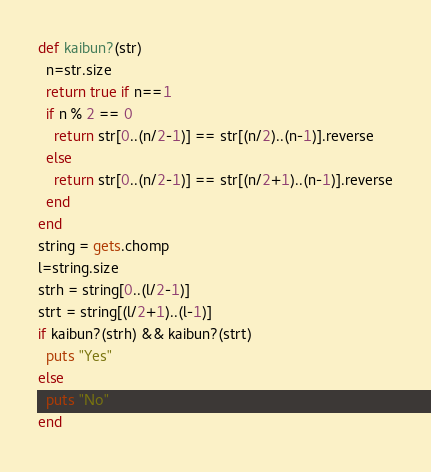Convert code to text. <code><loc_0><loc_0><loc_500><loc_500><_Ruby_>def kaibun?(str)
  n=str.size
  return true if n==1
  if n % 2 == 0
    return str[0..(n/2-1)] == str[(n/2)..(n-1)].reverse
  else
    return str[0..(n/2-1)] == str[(n/2+1)..(n-1)].reverse
  end
end
string = gets.chomp
l=string.size
strh = string[0..(l/2-1)]
strt = string[(l/2+1)..(l-1)]
if kaibun?(strh) && kaibun?(strt)
  puts "Yes"
else
  puts "No"
end</code> 